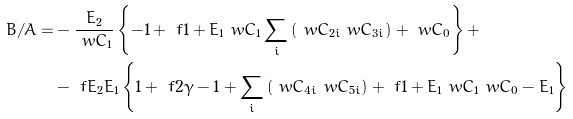Convert formula to latex. <formula><loc_0><loc_0><loc_500><loc_500>B / A = & - \frac { E _ { 2 } } { \ w { C } _ { 1 } } \left \{ - 1 + \ f { 1 + E _ { 1 } } { \ w { C } _ { 1 } } \sum _ { i } { ( \ w { C } _ { 2 i } \ w { C } _ { 3 i } ) } + \ w { C } _ { 0 } \right \} + \\ & - \ f { E _ { 2 } } { E _ { 1 } } \left \{ 1 + \ f { 2 } { \gamma - 1 } + \sum _ { i } { ( \ w { C } _ { 4 i } \ w { C } _ { 5 i } ) } + \ f { 1 + E _ { 1 } } { \ w { C } _ { 1 } } \ w { C } _ { 0 } - E _ { 1 } \right \}</formula> 